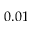Convert formula to latex. <formula><loc_0><loc_0><loc_500><loc_500>0 . 0 1</formula> 